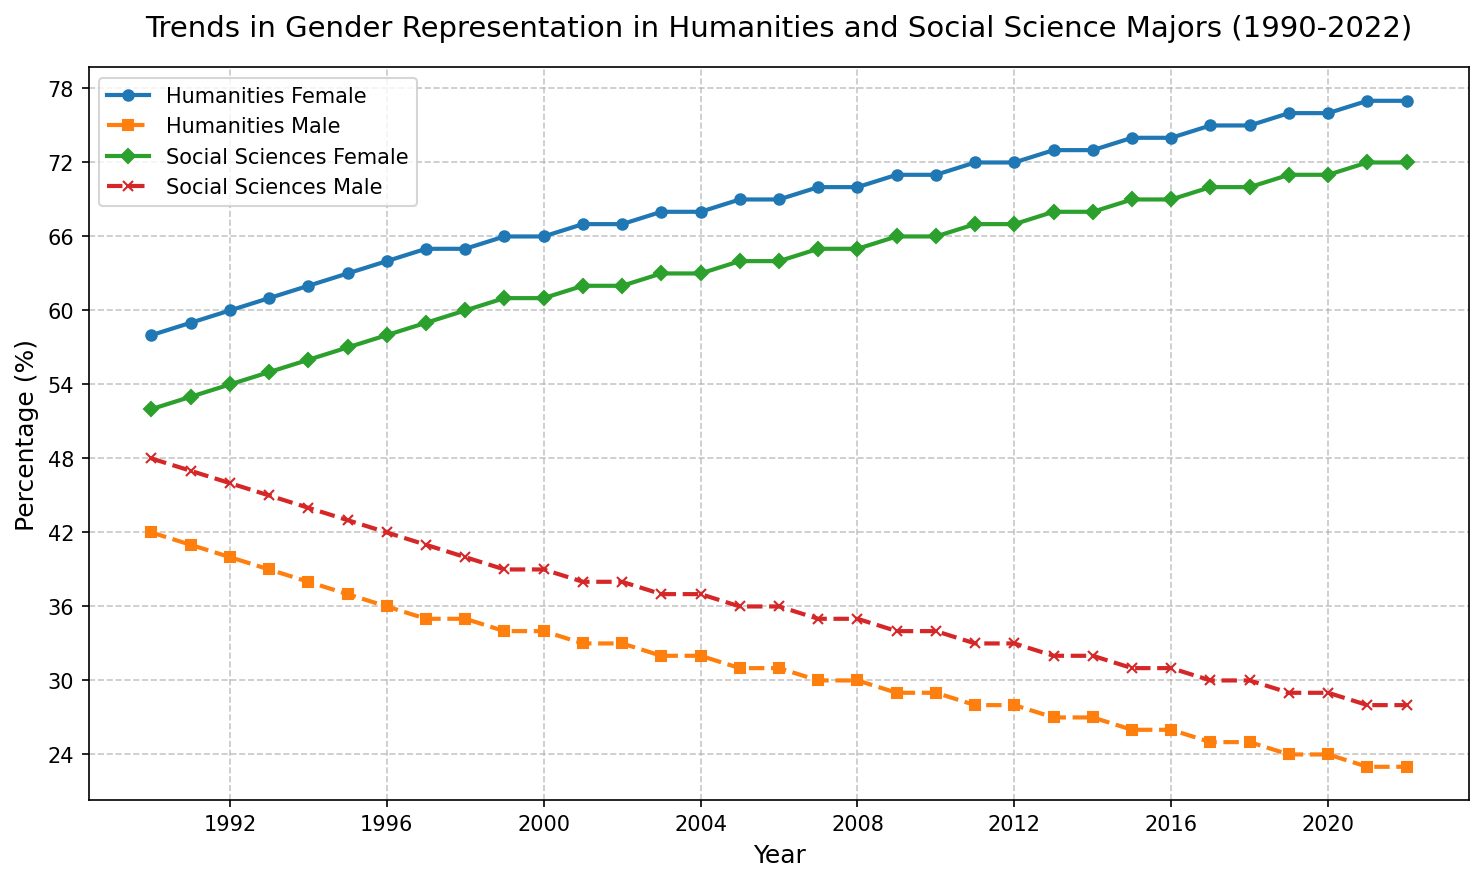What's the average percentage of female students in Humanities over the entire period? To find the average percentage, first sum all percentages from 1990 to 2022, i.e., 58 + 59 + 60 + ... + 77. Then divide this sum by the number of years, which is 33.
Answer: 67.5 Which year saw the highest percentage of female students in Social Sciences? By observing the chart, you can see that the line for Social Sciences Female peaks in 2021 and 2022 at 72%.
Answer: 2022 How did the representation of male students in Humanities change from 1990 to 2022? Subtract the percentage in 2022 (23%) from the percentage in 1990 (42%) to find the change. The change is 42% - 23% = 19%. The representation declined by 19 percentage points.
Answer: Declined by 19% In which years did the percentage of female students in Social Sciences equal the percentage in Humanities? Compare the lines for Social Sciences Female and Humanities Female. These two lines never intersect or equal each other.
Answer: Never What is the difference between the percentages of female and male students in Humanities in 2022? Subtract the percentage of Humanities Male (23%) from Humanities Female (77%) for the year 2022. The difference is 77% - 23% = 54%.
Answer: 54% What trends can be observed in the gender representation in Humanities compared to Social Sciences over the 30-year period? The percentage of female students consistently increased in both fields, with a larger increase in Humanities. Meanwhile, the percentage of male students consistently decreased in both fields.
Answer: Consistent increase for females, decrease for males From which year did the percentage of female students in Humanities exceed 70%? Look at the point where the Humanities Female line crosses 70%, which happens in 2007.
Answer: 2007 Did the percentage of male students in Social Sciences ever rise over the 30-year period? The line for Social Sciences Male consistently declines over the years from 1990 to 2022.
Answer: No Which field had a higher percentage of female students in 1995, Humanities or Social Sciences? Observe the points for 1995 in Humanities Female (63%) and Social Sciences Female (57%). Comparatively, Humanities had a higher percentage.
Answer: Humanities What is the total decline in percentage for male students in Social Sciences from 1990 to 2022? Subtract the percentage in 2022 (28%) from the percentage in 1990 (48%) to find the change: 48% - 28% = 20%.
Answer: 20% 